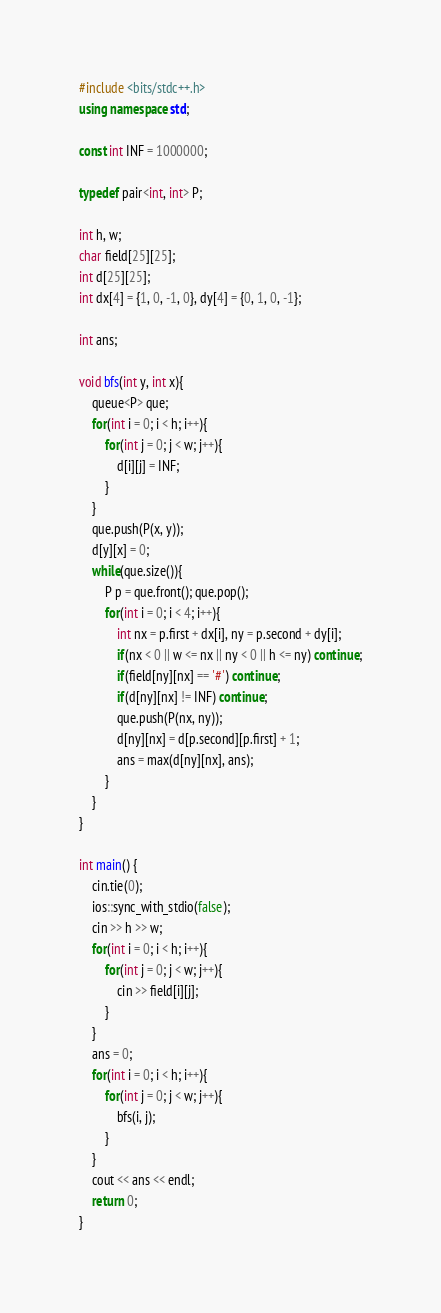Convert code to text. <code><loc_0><loc_0><loc_500><loc_500><_C++_>#include <bits/stdc++.h>
using namespace std;

const int INF = 1000000;

typedef pair<int, int> P;

int h, w;
char field[25][25];
int d[25][25];
int dx[4] = {1, 0, -1, 0}, dy[4] = {0, 1, 0, -1};

int ans;

void bfs(int y, int x){
	queue<P> que;
	for(int i = 0; i < h; i++){
		for(int j = 0; j < w; j++){
			d[i][j] = INF;
		}
	}
	que.push(P(x, y));
	d[y][x] = 0;
	while(que.size()){
		P p = que.front(); que.pop();
		for(int i = 0; i < 4; i++){
			int nx = p.first + dx[i], ny = p.second + dy[i];
			if(nx < 0 || w <= nx || ny < 0 || h <= ny) continue;
			if(field[ny][nx] == '#') continue;
			if(d[ny][nx] != INF) continue;
			que.push(P(nx, ny));
			d[ny][nx] = d[p.second][p.first] + 1;
			ans = max(d[ny][nx], ans);
		}
	}
}

int main() {
	cin.tie(0);
	ios::sync_with_stdio(false);
	cin >> h >> w;
	for(int i = 0; i < h; i++){
		for(int j = 0; j < w; j++){
			cin >> field[i][j];
		}
	}
	ans = 0;
	for(int i = 0; i < h; i++){
		for(int j = 0; j < w; j++){
			bfs(i, j);
		}
	}
	cout << ans << endl;
	return 0;
}</code> 